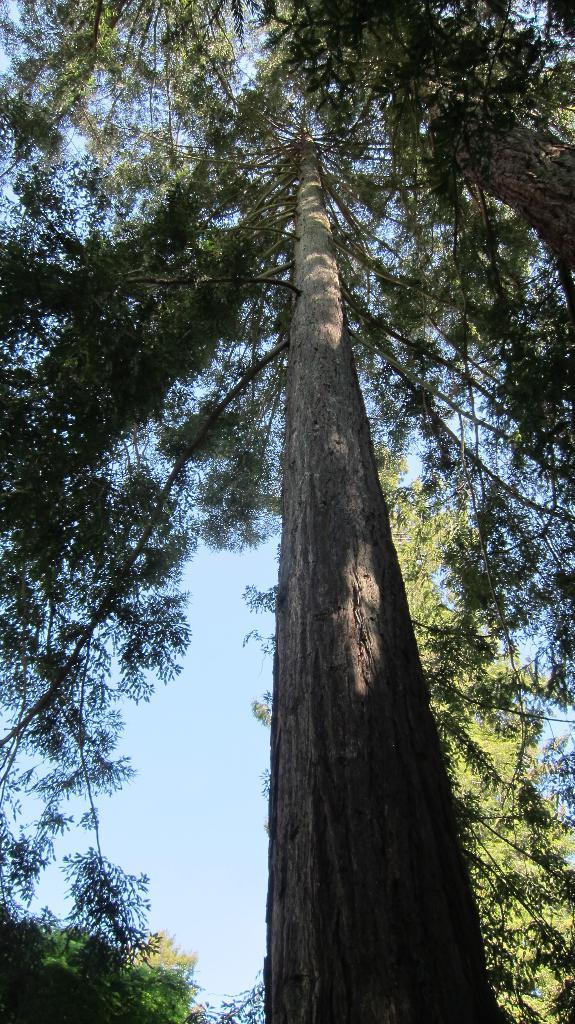What type of vegetation can be seen in the image? There are trees in the image. What part of the natural environment is visible in the image? The sky is visible in the background of the image. What type of picture is hanging on the trees in the image? There is no picture hanging on the trees in the image; only trees and the sky are visible. What is the temper of the trees in the image? Trees do not have a temper; they are inanimate objects. 